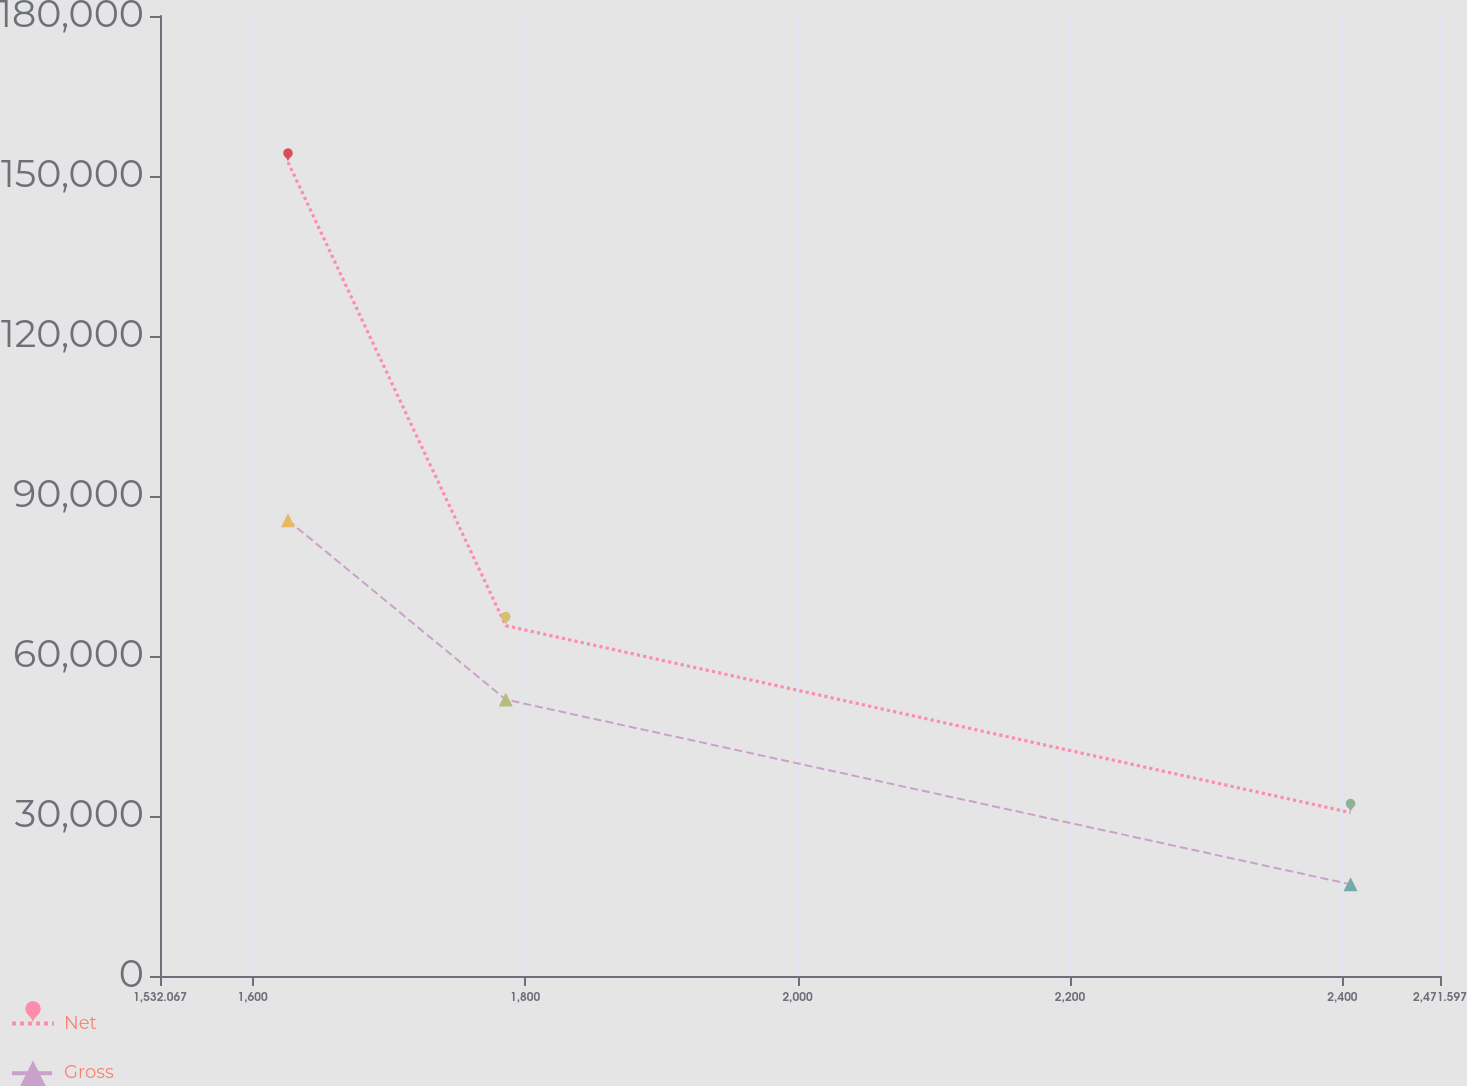Convert chart to OTSL. <chart><loc_0><loc_0><loc_500><loc_500><line_chart><ecel><fcel>Net<fcel>Gross<nl><fcel>1626.02<fcel>152587<fcel>85442.9<nl><fcel>1785.86<fcel>65683.4<fcel>51831.6<nl><fcel>2405.93<fcel>30635<fcel>17192.9<nl><fcel>2485.74<fcel>146.91<fcel>130.41<nl><fcel>2565.55<fcel>15391<fcel>8661.66<nl></chart> 